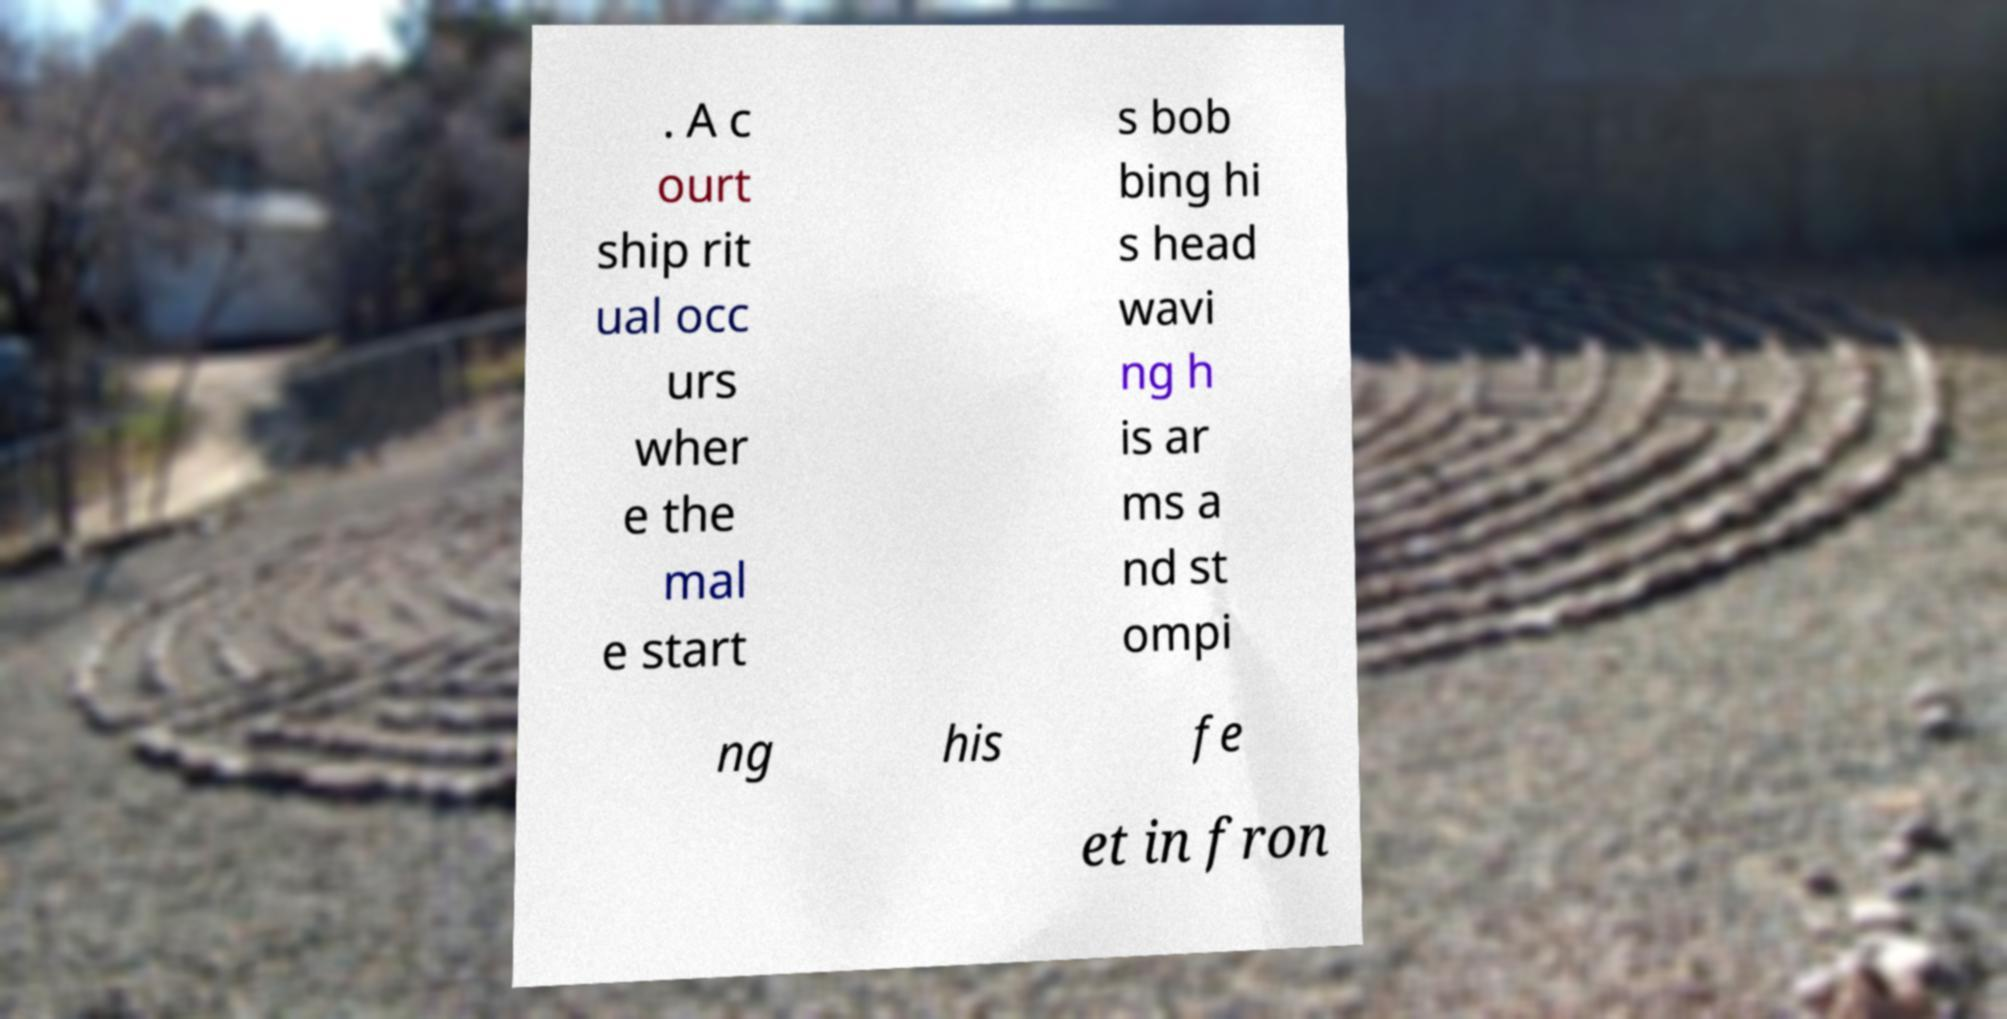What messages or text are displayed in this image? I need them in a readable, typed format. . A c ourt ship rit ual occ urs wher e the mal e start s bob bing hi s head wavi ng h is ar ms a nd st ompi ng his fe et in fron 